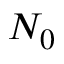<formula> <loc_0><loc_0><loc_500><loc_500>N _ { 0 }</formula> 